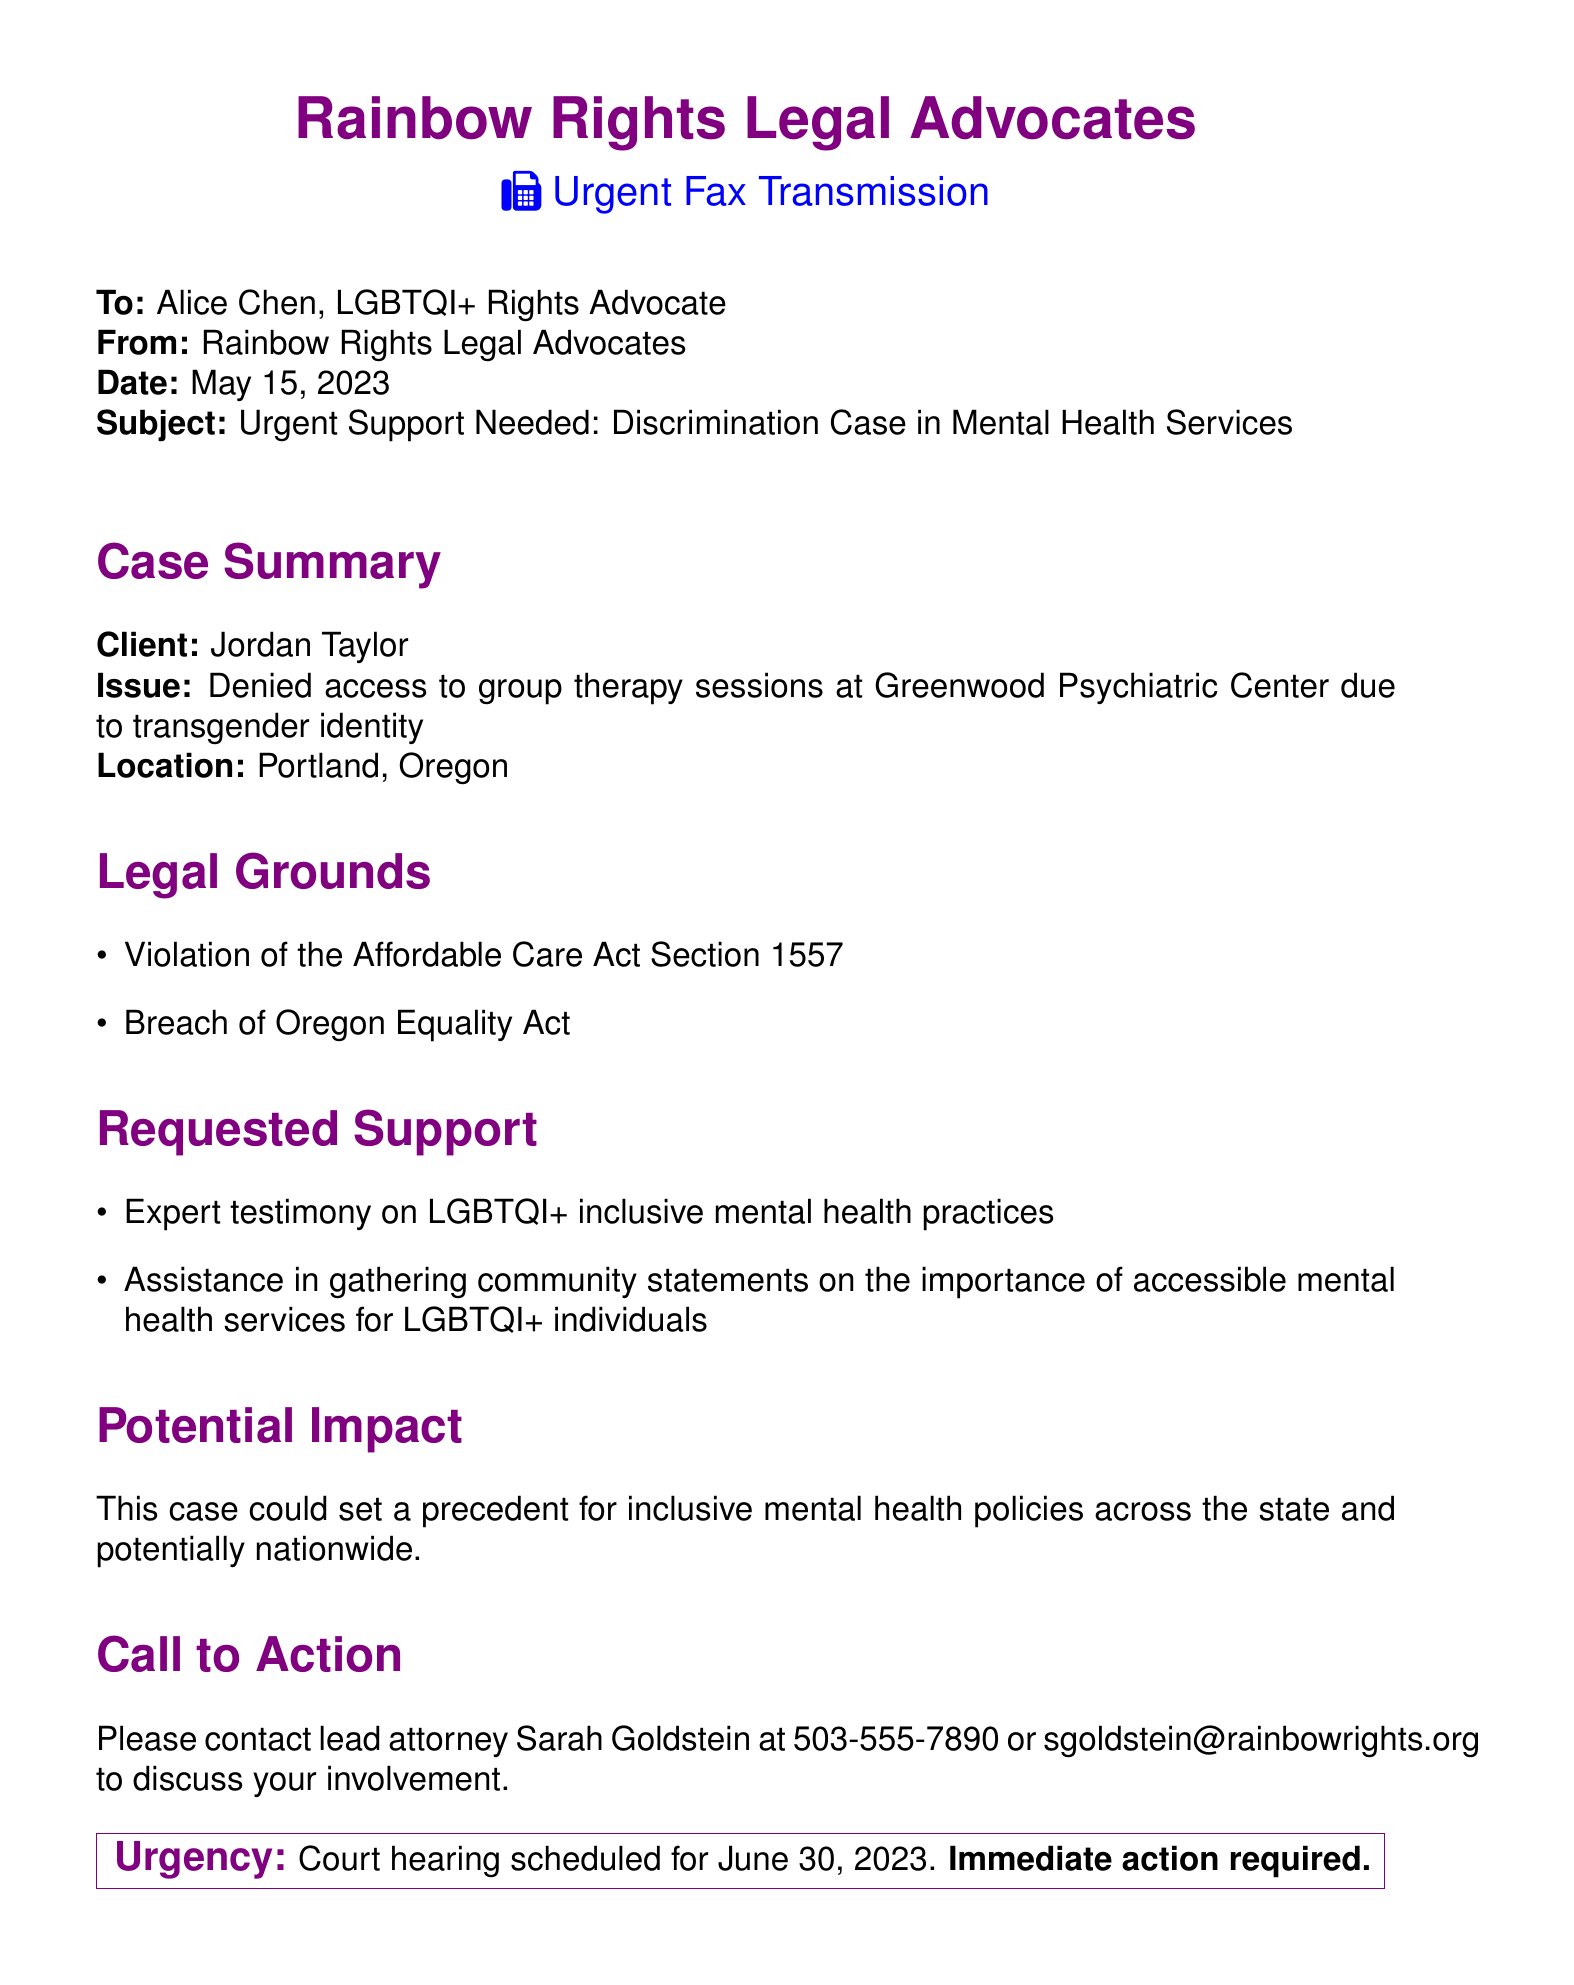What is the client's name? The client's name is mentioned in the case summary section of the document as Jordan Taylor.
Answer: Jordan Taylor What is the issue faced by the client? The issue is stated in the case summary section and involves being denied access to group therapy sessions due to transgender identity.
Answer: Denied access to group therapy sessions due to transgender identity Where is the case located? The location of the case is specified in the case summary section as Portland, Oregon.
Answer: Portland, Oregon What legal grounds are cited in the document? The document lists legal grounds under two acts: the Affordable Care Act Section 1557 and the Oregon Equality Act.
Answer: Violation of the Affordable Care Act Section 1557, Breach of Oregon Equality Act What type of support is being requested? The document specifies two types of support requested: expert testimony on LGBTQI+ inclusive mental health practices and assistance in gathering community statements.
Answer: Expert testimony and assistance in gathering community statements When is the court hearing scheduled? The due date for the court hearing is stated in the urgency section of the document as June 30, 2023.
Answer: June 30, 2023 Who should be contacted for involvement? The document specifies the lead attorney to contact for involvement as Sarah Goldstein.
Answer: Sarah Goldstein What is the potential impact of this case? The potential impact mentioned in the document is that this case could set a precedent for inclusive mental health policies across the state and potentially nationwide.
Answer: Set a precedent for inclusive mental health policies 